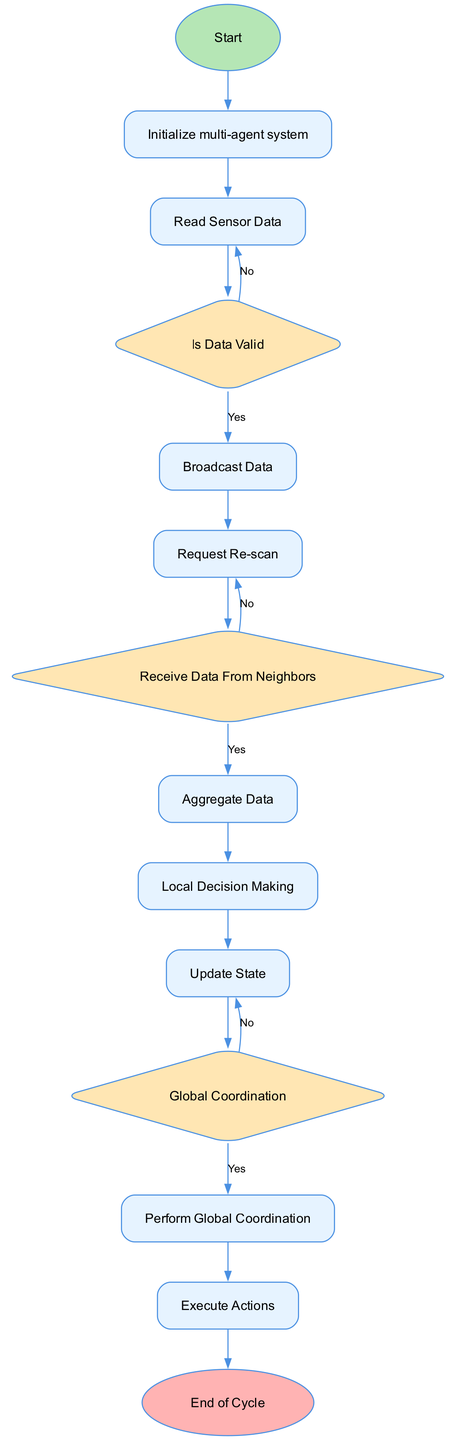What is the first action each agent performs in the diagram? The diagram starts with the "Initialize multi-agent system", providing context that the first action is to prepare the system for operation.
Answer: Initialize multi-agent system How many decisions are present in the diagram? By counting the nodes classified as "decision" in the diagram, we identify three decision points: "Is Data Valid", "Receive Data From Neighbors", and "Global Coordination".
Answer: Three What happens if the sensor data is invalid? The diagram specifies that in the case of invalid data, the action "Request Re-scan" is triggered to obtain new sensor data.
Answer: Request Re-scan What follows the action "Aggregate Data"? The flow from the diagram indicates that after "Aggregate Data", the next step is "Local Decision Making", where decisions are made based on aggregated information.
Answer: Local Decision Making Which action comes after "Perform Global Coordination"? According to the structured flow of the diagram, the action that follows "Perform Global Coordination" is "Execute Actions", where agents carry out their determined actions.
Answer: Execute Actions What is the terminal action indicating the completion of the cycle? The diagram includes the terminal action "End of Cycle" that signifies the conclusion of the current coordination cycle for the multi-agent system.
Answer: End of Cycle How many actions are there in the diagram? Analyzing the nodes classified as "action", we find six actions: "Read Sensor Data," "Broadcast Data," "Request Re-scan," "Aggregate Data," "Local Decision Making," and "Execute Actions".
Answer: Six When checking for global coordination, what are the possible outcomes? The decision node "Global Coordination" leads to two possible outcomes based on the decision made: if global coordination is required, proceed to "Perform Global Coordination"; otherwise, continue without it.
Answer: Yes or No What is the purpose of the "Local Decision Making" action? The diagram indicates that "Local Decision Making" allows each agent to make decisions based on the combined data from its own sensors and neighboring agents, essential for localized control.
Answer: Make decisions based on aggregated data 